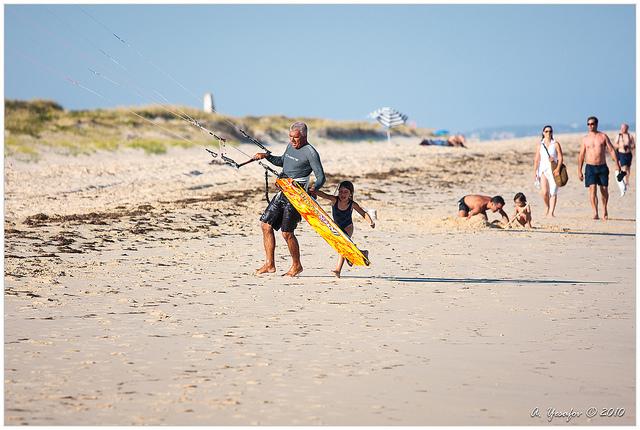Is the man in gray under 20 years old?
Concise answer only. No. How many dogs are visible?
Write a very short answer. 0. Is there an umbrella around?
Keep it brief. Yes. Does this scene look warm or cold?
Give a very brief answer. Warm. 